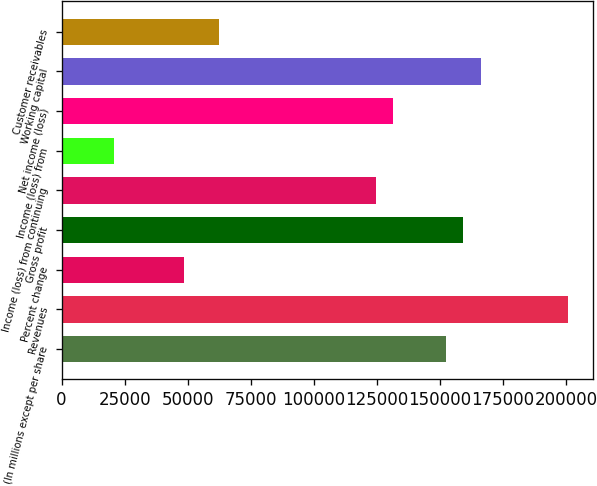<chart> <loc_0><loc_0><loc_500><loc_500><bar_chart><fcel>(In millions except per share<fcel>Revenues<fcel>Percent change<fcel>Gross profit<fcel>Income (loss) from continuing<fcel>Income (loss) from<fcel>Net income (loss)<fcel>Working capital<fcel>Customer receivables<nl><fcel>152262<fcel>200709<fcel>48447.1<fcel>159183<fcel>124578<fcel>20763.2<fcel>131499<fcel>166104<fcel>62289.1<nl></chart> 